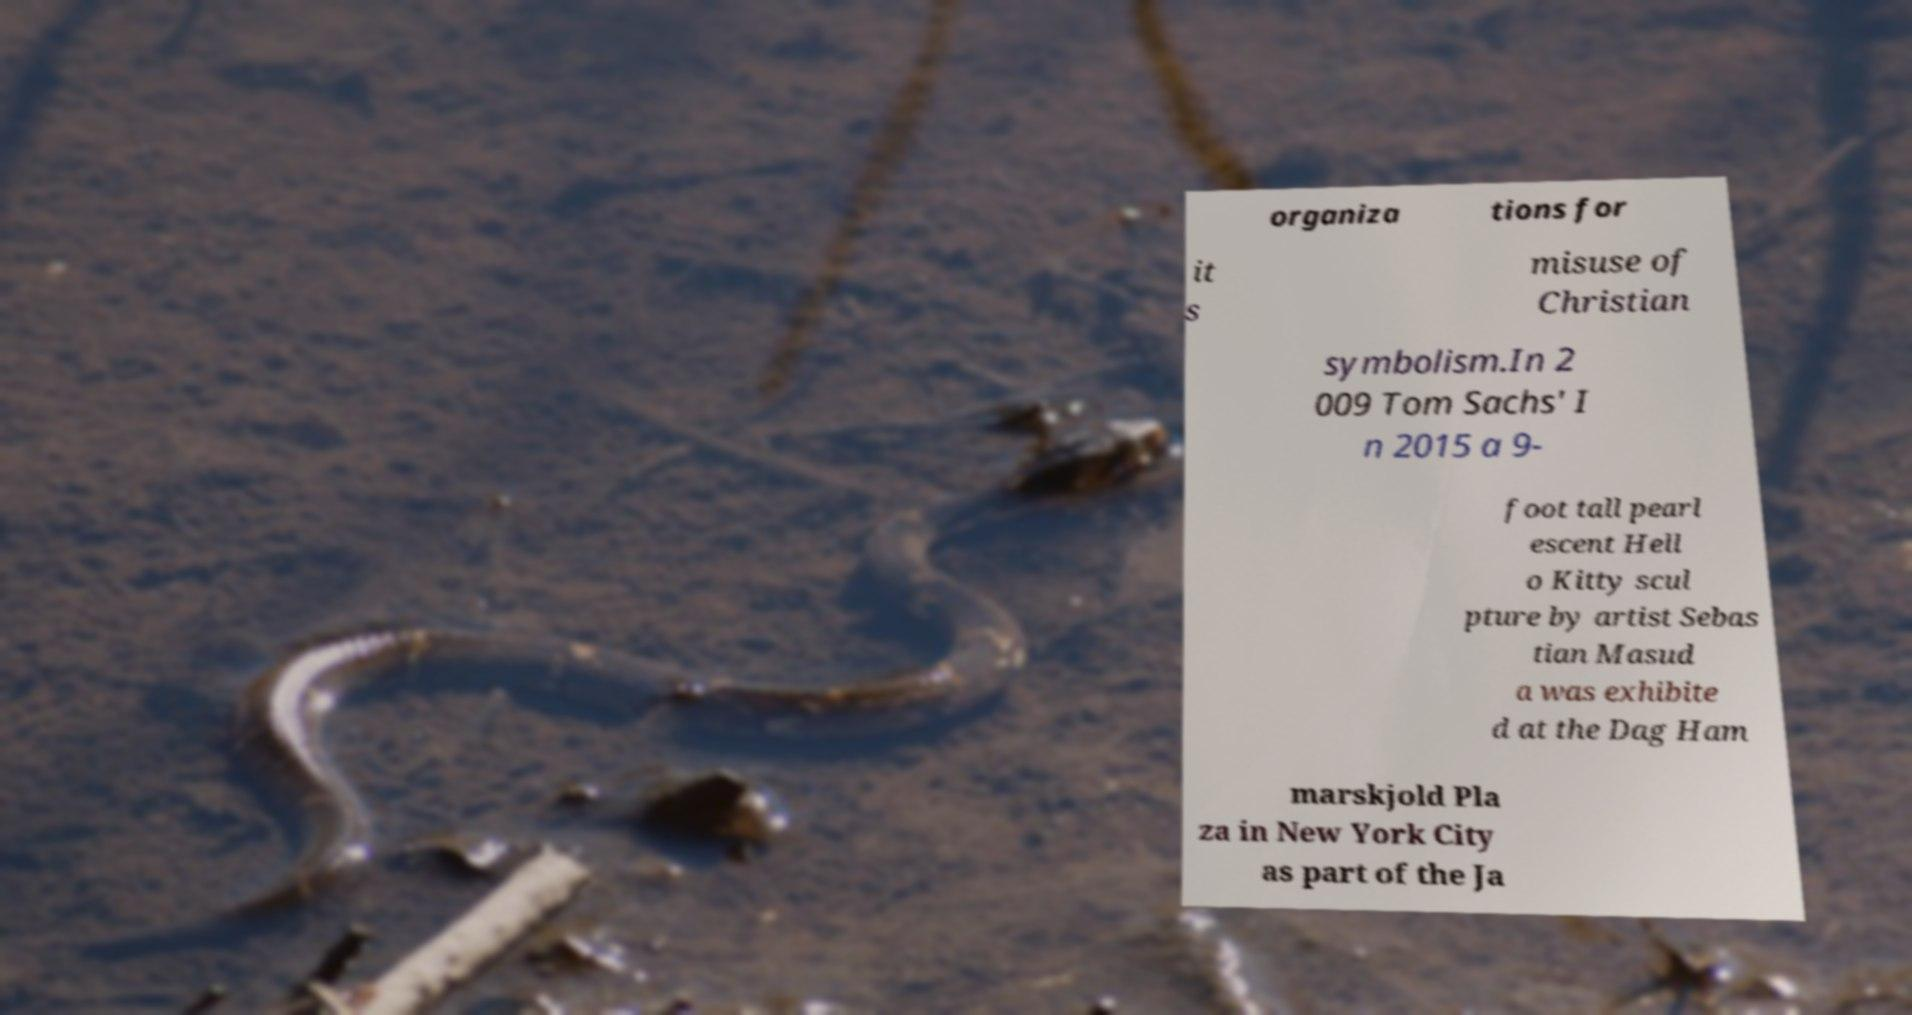Please read and relay the text visible in this image. What does it say? organiza tions for it s misuse of Christian symbolism.In 2 009 Tom Sachs' I n 2015 a 9- foot tall pearl escent Hell o Kitty scul pture by artist Sebas tian Masud a was exhibite d at the Dag Ham marskjold Pla za in New York City as part of the Ja 